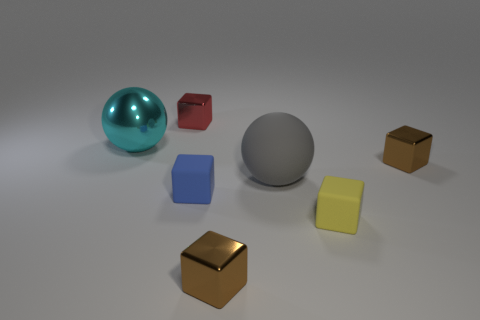How many cyan things are shiny things or large matte spheres?
Your answer should be compact. 1. What number of metallic objects are left of the small red block and behind the big cyan sphere?
Your answer should be compact. 0. What is the material of the large thing that is behind the brown shiny object that is to the right of the tiny metal cube that is in front of the gray rubber thing?
Your response must be concise. Metal. How many small yellow objects are made of the same material as the gray thing?
Give a very brief answer. 1. There is another object that is the same size as the gray object; what is its shape?
Your answer should be compact. Sphere. There is a big cyan sphere; are there any brown things to the left of it?
Make the answer very short. No. Are there any large cyan objects that have the same shape as the gray thing?
Make the answer very short. Yes. Does the brown object behind the yellow rubber block have the same shape as the brown object that is to the left of the gray rubber ball?
Your answer should be very brief. Yes. Is there another cyan sphere that has the same size as the rubber sphere?
Offer a terse response. Yes. Are there an equal number of small brown metal blocks behind the large gray thing and small rubber objects that are in front of the blue block?
Your answer should be compact. Yes. 